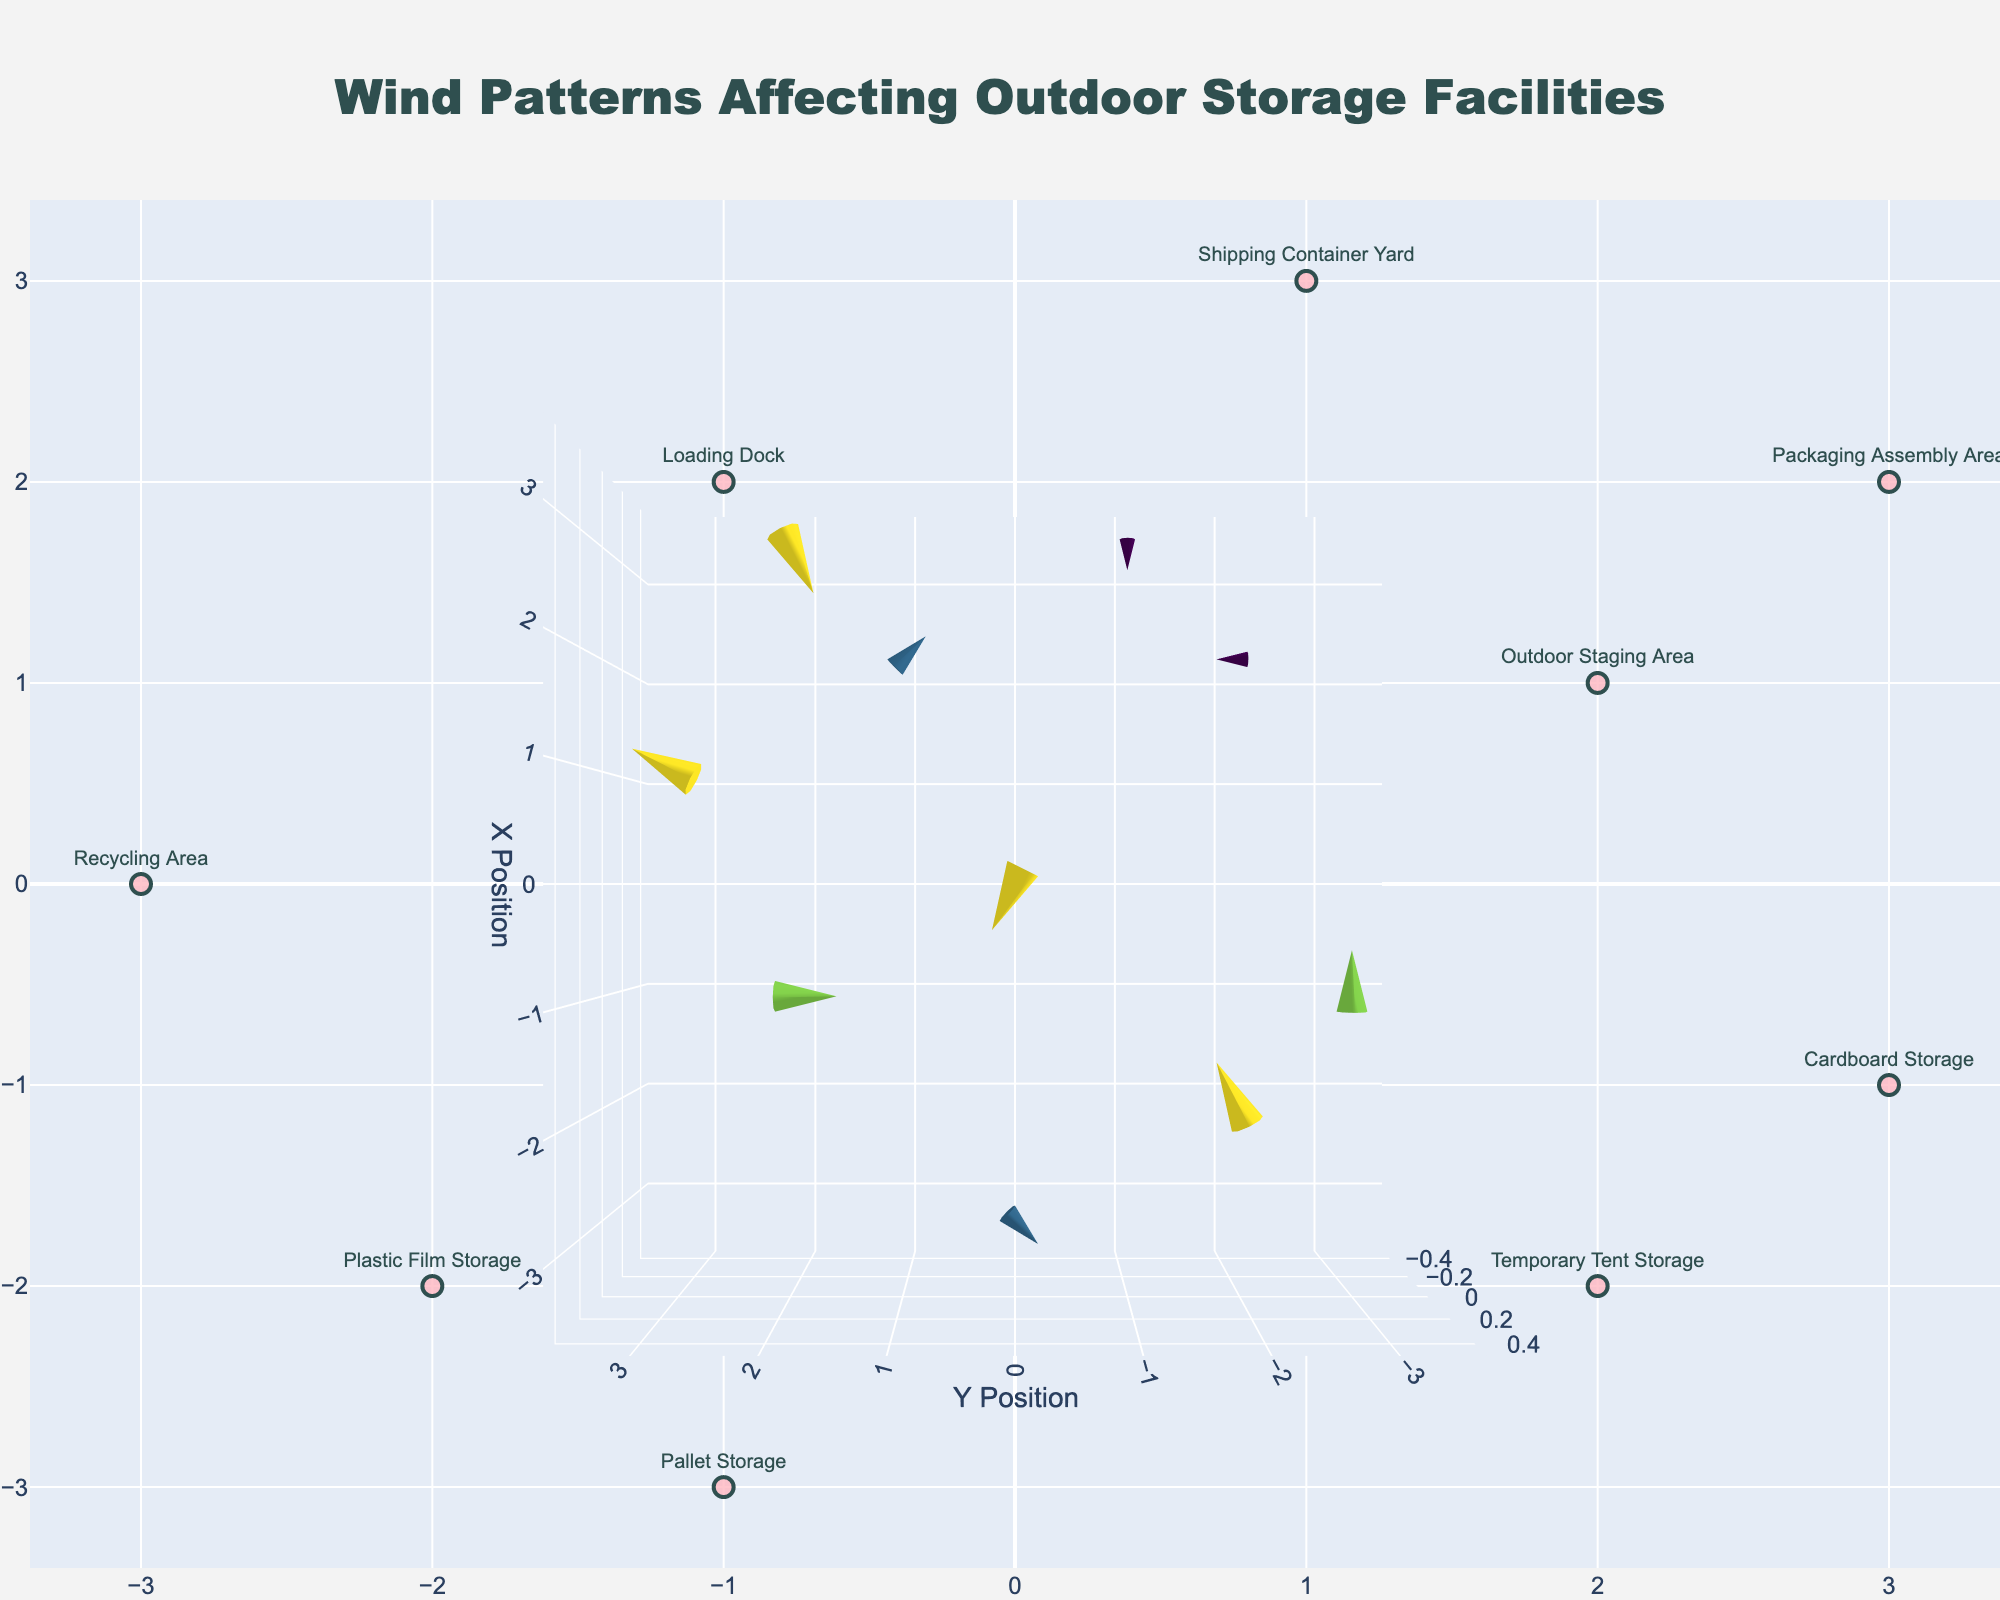How many data points are shown in the plot? Count the number of markers or vectors displayed in the figure. Since we have one marker or vector for each data point, the total number of data points can be counted directly.
Answer: 10 Which location has the strongest northward wind component? Look for the vector with the highest positive value in the north (upward) direction; this determines the location with the strongest northward wind. From the data, "Shipping Container Yard" has the highest northward component of 2.
Answer: Shipping Container Yard Which location experiences a westward wind? Look for vectors pointing to the left (west). From the data, both "Recycling Area" and "Packaging Assembly Area" have a westward wind component with vectors pointing left.
Answer: Recycling Area, Packaging Assembly Area What is the net wind effect at the "Pallet Storage" location? Check the components of the wind vector at the "Pallet Storage" location, it has an eastward component of 2 and no northward or southward component. Thus, the net wind effect is eastward.
Answer: Eastward Compare the magnitude of wind at "Main Storage Facility" and "Temporary Tent Storage". Which is stronger? Calculate the vector magnitude for each location using the formula magnitude = sqrt(u^2 + v^2). Main Storage Facility: sqrt((-2)^2 + 1^2) = sqrt(5). Temporary Tent Storage: sqrt(0^2 + 1^2) = sqrt(1).
Answer: Main Storage Facility Which location has the most varied wind directions? Look for the location where the wind components (u and v) are both non-zero and where directions are evenly distributed. "Shipping Container Yard" has both non-zero components with a significant positive u and v value showing varied directions.
Answer: Shipping Container Yard What is the average southward wind component across all locations? Calculate the mean of all negative v components. The southward components are -1, -2, and -1. Average = (-1 + -2 + -1)/3 = -4/3.
Answer: -4/3 If you want to avoid storing materials in windy conditions, which location would be the safest based on the plot? Identify the location with the smallest wind vector magnitude. "Temporary Tent Storage" has a magnitude of 1, which is the smallest among all.
Answer: Temporary Tent Storage 